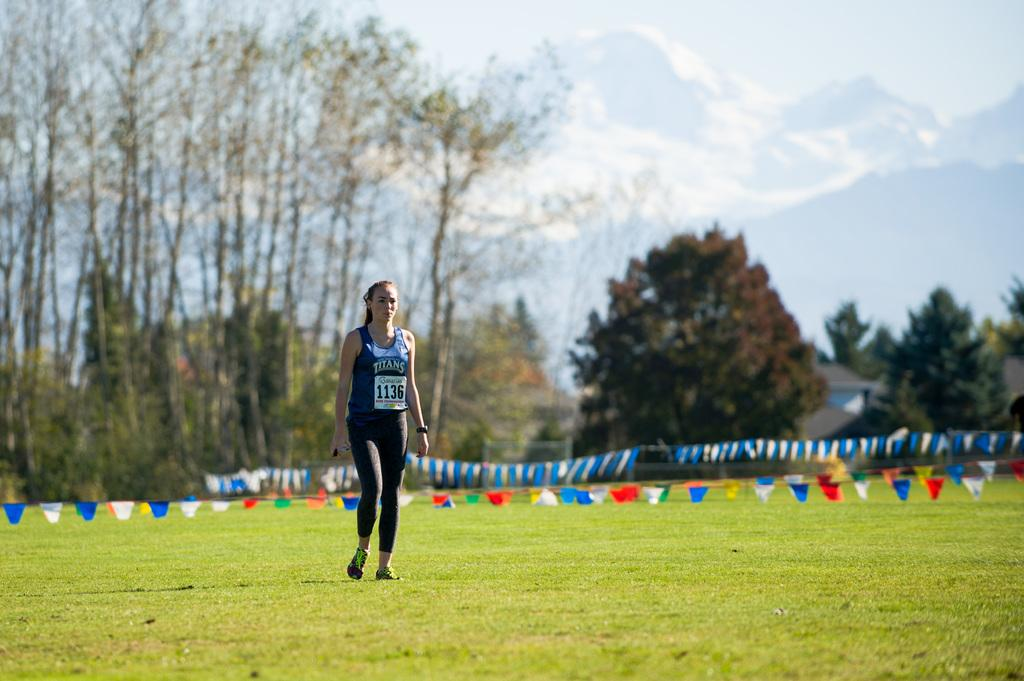<image>
Present a compact description of the photo's key features. A woman in a titans running shirt with the number 1136 on her stomach. 